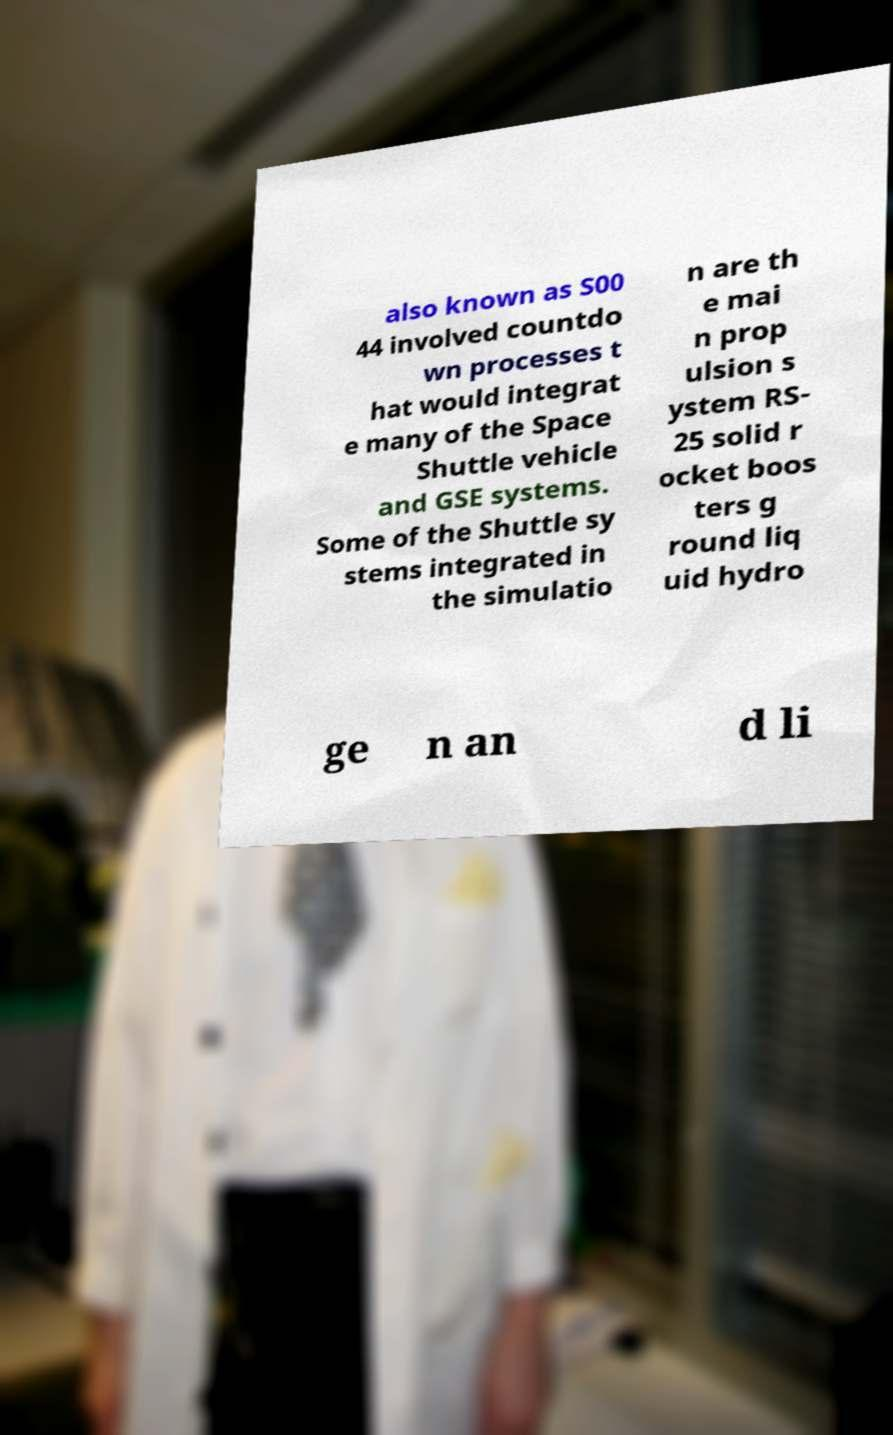Please read and relay the text visible in this image. What does it say? also known as S00 44 involved countdo wn processes t hat would integrat e many of the Space Shuttle vehicle and GSE systems. Some of the Shuttle sy stems integrated in the simulatio n are th e mai n prop ulsion s ystem RS- 25 solid r ocket boos ters g round liq uid hydro ge n an d li 